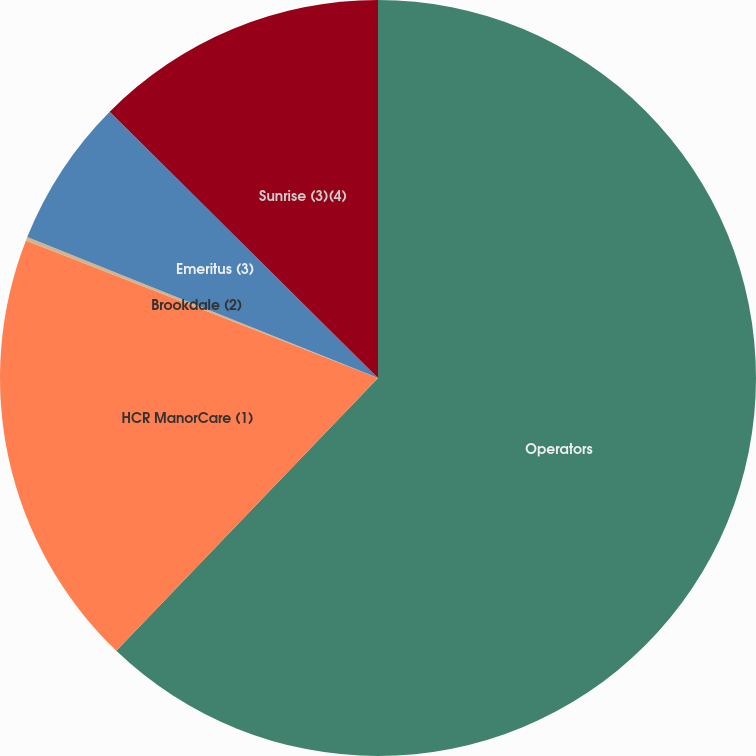Convert chart. <chart><loc_0><loc_0><loc_500><loc_500><pie_chart><fcel>Operators<fcel>HCR ManorCare (1)<fcel>Brookdale (2)<fcel>Emeritus (3)<fcel>Sunrise (3)(4)<nl><fcel>62.17%<fcel>18.76%<fcel>0.15%<fcel>6.36%<fcel>12.56%<nl></chart> 